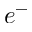<formula> <loc_0><loc_0><loc_500><loc_500>e ^ { - }</formula> 